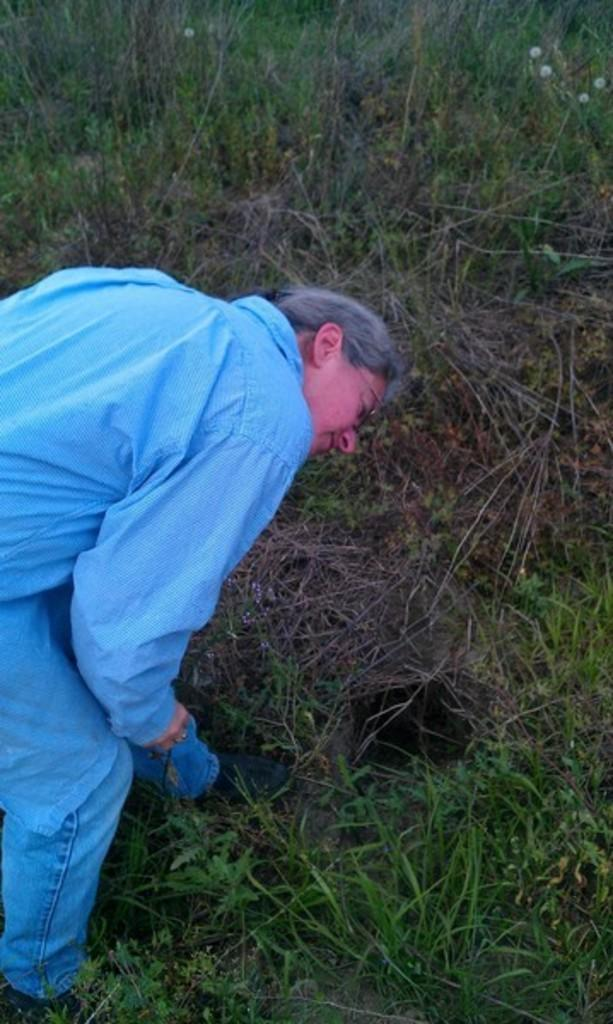What type of vegetation is present on the ground in the image? There is: There is green grass on the ground in the image. Can you describe the person in the image? There is a person on the left side of the image. What accessory is the person wearing? The person is wearing glasses (specs). What type of muscle is being exercised by the ducks in the image? There are no ducks present in the image, so it is not possible to determine which muscles might be exercised. 